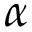<formula> <loc_0><loc_0><loc_500><loc_500>\alpha</formula> 